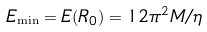Convert formula to latex. <formula><loc_0><loc_0><loc_500><loc_500>E _ { \min } = E ( R _ { 0 } ) = 1 2 \pi ^ { 2 } M / \eta</formula> 